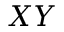<formula> <loc_0><loc_0><loc_500><loc_500>X Y</formula> 